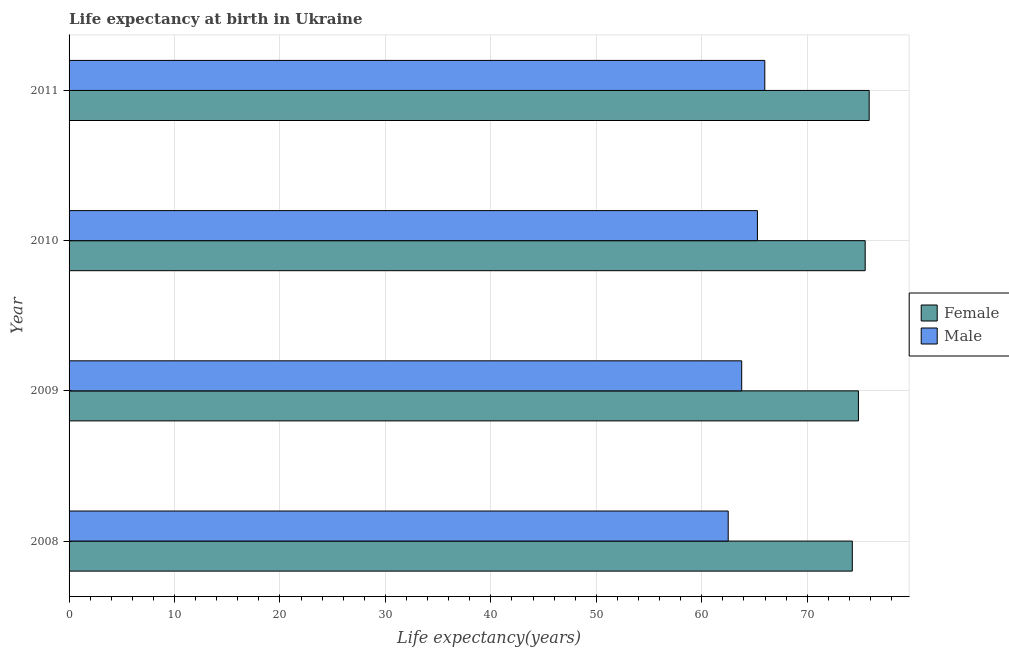How many groups of bars are there?
Your response must be concise. 4. Are the number of bars on each tick of the Y-axis equal?
Ensure brevity in your answer.  Yes. How many bars are there on the 2nd tick from the top?
Provide a succinct answer. 2. How many bars are there on the 3rd tick from the bottom?
Your answer should be very brief. 2. What is the label of the 2nd group of bars from the top?
Ensure brevity in your answer.  2010. In how many cases, is the number of bars for a given year not equal to the number of legend labels?
Provide a succinct answer. 0. What is the life expectancy(male) in 2008?
Give a very brief answer. 62.51. Across all years, what is the maximum life expectancy(male)?
Keep it short and to the point. 65.98. Across all years, what is the minimum life expectancy(female)?
Provide a succinct answer. 74.28. What is the total life expectancy(female) in the graph?
Offer a very short reply. 300.52. What is the difference between the life expectancy(male) in 2009 and that in 2010?
Ensure brevity in your answer.  -1.49. What is the difference between the life expectancy(male) in 2008 and the life expectancy(female) in 2011?
Provide a succinct answer. -13.37. What is the average life expectancy(female) per year?
Ensure brevity in your answer.  75.13. In the year 2010, what is the difference between the life expectancy(female) and life expectancy(male)?
Give a very brief answer. 10.22. What is the ratio of the life expectancy(male) in 2008 to that in 2011?
Ensure brevity in your answer.  0.95. What is the difference between the highest and the second highest life expectancy(male)?
Your answer should be very brief. 0.7. What does the 1st bar from the top in 2011 represents?
Your answer should be compact. Male. What is the difference between two consecutive major ticks on the X-axis?
Provide a succinct answer. 10. Does the graph contain grids?
Your answer should be compact. Yes. Where does the legend appear in the graph?
Make the answer very short. Center right. How many legend labels are there?
Your answer should be very brief. 2. What is the title of the graph?
Provide a succinct answer. Life expectancy at birth in Ukraine. What is the label or title of the X-axis?
Ensure brevity in your answer.  Life expectancy(years). What is the label or title of the Y-axis?
Your answer should be very brief. Year. What is the Life expectancy(years) in Female in 2008?
Make the answer very short. 74.28. What is the Life expectancy(years) in Male in 2008?
Offer a very short reply. 62.51. What is the Life expectancy(years) in Female in 2009?
Your response must be concise. 74.86. What is the Life expectancy(years) in Male in 2009?
Give a very brief answer. 63.79. What is the Life expectancy(years) of Female in 2010?
Ensure brevity in your answer.  75.5. What is the Life expectancy(years) of Male in 2010?
Make the answer very short. 65.28. What is the Life expectancy(years) of Female in 2011?
Give a very brief answer. 75.88. What is the Life expectancy(years) of Male in 2011?
Your response must be concise. 65.98. Across all years, what is the maximum Life expectancy(years) in Female?
Your response must be concise. 75.88. Across all years, what is the maximum Life expectancy(years) of Male?
Make the answer very short. 65.98. Across all years, what is the minimum Life expectancy(years) of Female?
Your response must be concise. 74.28. Across all years, what is the minimum Life expectancy(years) in Male?
Offer a very short reply. 62.51. What is the total Life expectancy(years) in Female in the graph?
Your answer should be very brief. 300.52. What is the total Life expectancy(years) in Male in the graph?
Offer a terse response. 257.56. What is the difference between the Life expectancy(years) of Female in 2008 and that in 2009?
Provide a succinct answer. -0.58. What is the difference between the Life expectancy(years) in Male in 2008 and that in 2009?
Your response must be concise. -1.28. What is the difference between the Life expectancy(years) of Female in 2008 and that in 2010?
Provide a short and direct response. -1.22. What is the difference between the Life expectancy(years) in Male in 2008 and that in 2010?
Make the answer very short. -2.77. What is the difference between the Life expectancy(years) of Male in 2008 and that in 2011?
Offer a very short reply. -3.47. What is the difference between the Life expectancy(years) of Female in 2009 and that in 2010?
Provide a succinct answer. -0.64. What is the difference between the Life expectancy(years) of Male in 2009 and that in 2010?
Your response must be concise. -1.49. What is the difference between the Life expectancy(years) in Female in 2009 and that in 2011?
Give a very brief answer. -1.02. What is the difference between the Life expectancy(years) in Male in 2009 and that in 2011?
Keep it short and to the point. -2.19. What is the difference between the Life expectancy(years) in Female in 2010 and that in 2011?
Keep it short and to the point. -0.38. What is the difference between the Life expectancy(years) in Female in 2008 and the Life expectancy(years) in Male in 2009?
Your answer should be compact. 10.49. What is the difference between the Life expectancy(years) in Female in 2008 and the Life expectancy(years) in Male in 2011?
Give a very brief answer. 8.3. What is the difference between the Life expectancy(years) in Female in 2009 and the Life expectancy(years) in Male in 2010?
Your response must be concise. 9.58. What is the difference between the Life expectancy(years) in Female in 2009 and the Life expectancy(years) in Male in 2011?
Your answer should be very brief. 8.88. What is the difference between the Life expectancy(years) of Female in 2010 and the Life expectancy(years) of Male in 2011?
Offer a very short reply. 9.52. What is the average Life expectancy(years) of Female per year?
Provide a succinct answer. 75.13. What is the average Life expectancy(years) in Male per year?
Keep it short and to the point. 64.39. In the year 2008, what is the difference between the Life expectancy(years) of Female and Life expectancy(years) of Male?
Your answer should be very brief. 11.77. In the year 2009, what is the difference between the Life expectancy(years) in Female and Life expectancy(years) in Male?
Provide a succinct answer. 11.07. In the year 2010, what is the difference between the Life expectancy(years) in Female and Life expectancy(years) in Male?
Provide a short and direct response. 10.22. In the year 2011, what is the difference between the Life expectancy(years) in Female and Life expectancy(years) in Male?
Keep it short and to the point. 9.9. What is the ratio of the Life expectancy(years) in Male in 2008 to that in 2009?
Provide a succinct answer. 0.98. What is the ratio of the Life expectancy(years) of Female in 2008 to that in 2010?
Provide a short and direct response. 0.98. What is the ratio of the Life expectancy(years) of Male in 2008 to that in 2010?
Give a very brief answer. 0.96. What is the ratio of the Life expectancy(years) in Female in 2008 to that in 2011?
Your answer should be very brief. 0.98. What is the ratio of the Life expectancy(years) in Male in 2009 to that in 2010?
Your response must be concise. 0.98. What is the ratio of the Life expectancy(years) of Female in 2009 to that in 2011?
Offer a very short reply. 0.99. What is the ratio of the Life expectancy(years) in Male in 2009 to that in 2011?
Make the answer very short. 0.97. What is the ratio of the Life expectancy(years) in Female in 2010 to that in 2011?
Keep it short and to the point. 0.99. What is the ratio of the Life expectancy(years) of Male in 2010 to that in 2011?
Make the answer very short. 0.99. What is the difference between the highest and the second highest Life expectancy(years) in Female?
Keep it short and to the point. 0.38. What is the difference between the highest and the second highest Life expectancy(years) in Male?
Provide a succinct answer. 0.7. What is the difference between the highest and the lowest Life expectancy(years) of Male?
Your answer should be very brief. 3.47. 